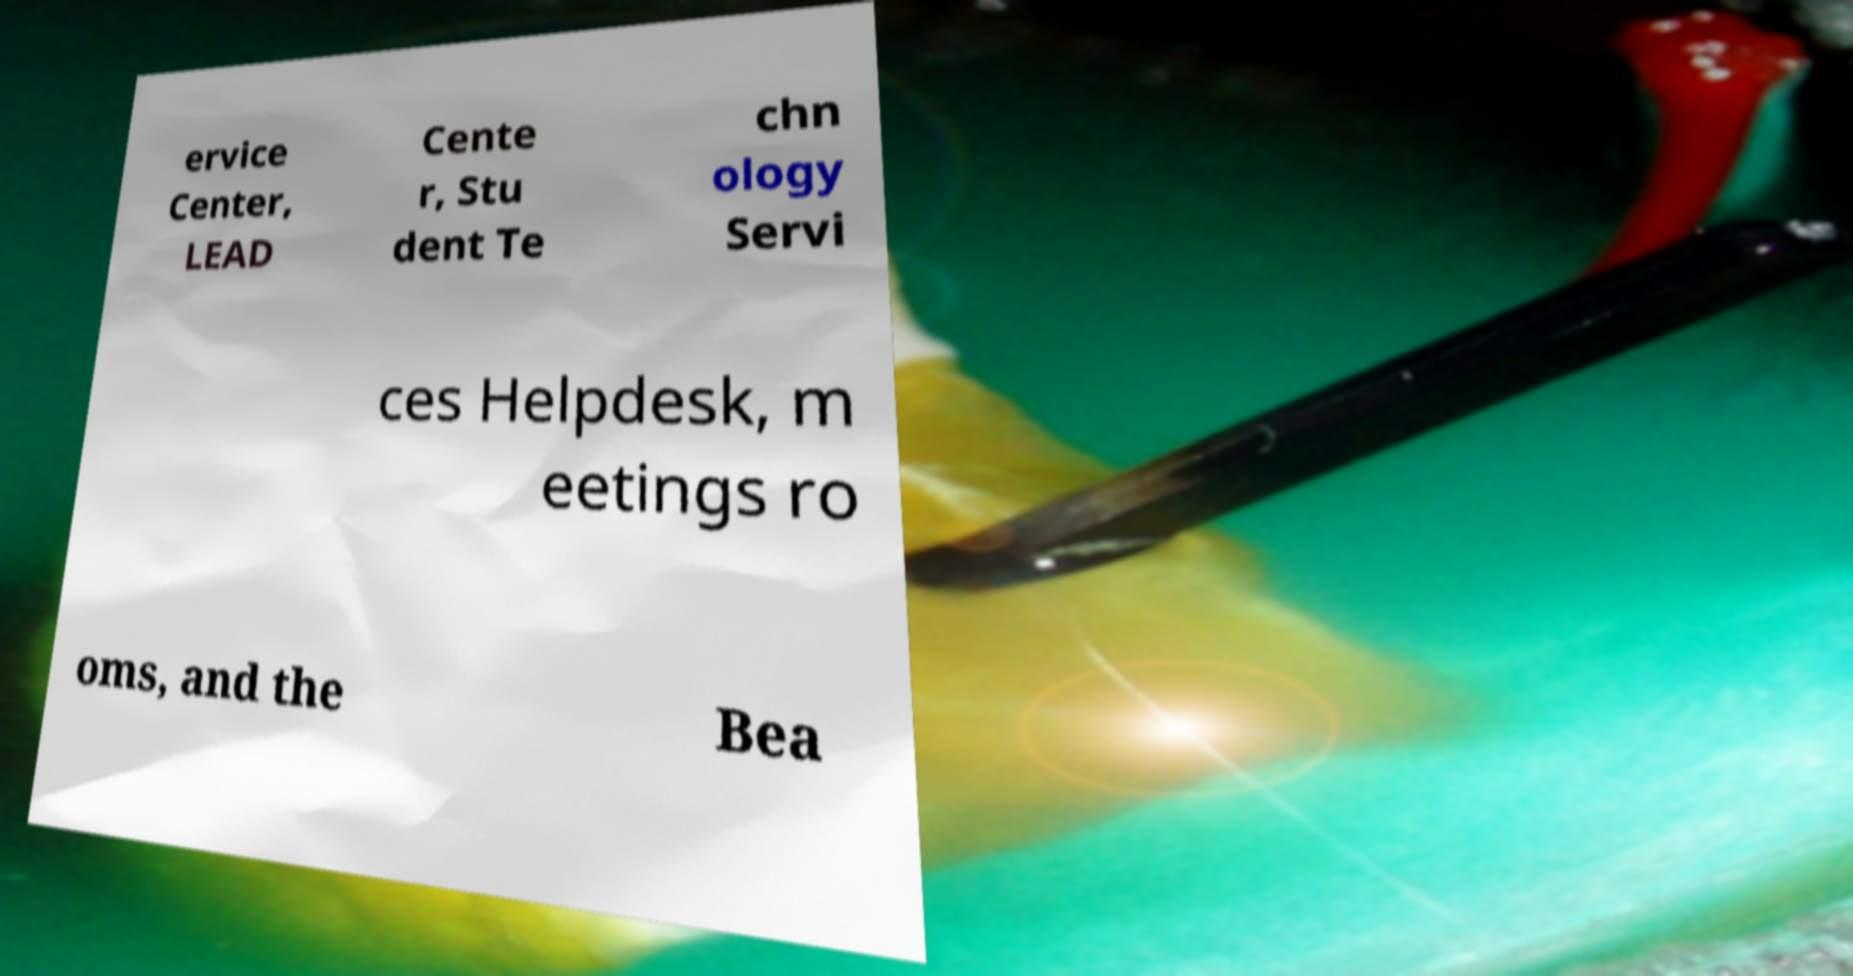Could you assist in decoding the text presented in this image and type it out clearly? ervice Center, LEAD Cente r, Stu dent Te chn ology Servi ces Helpdesk, m eetings ro oms, and the Bea 